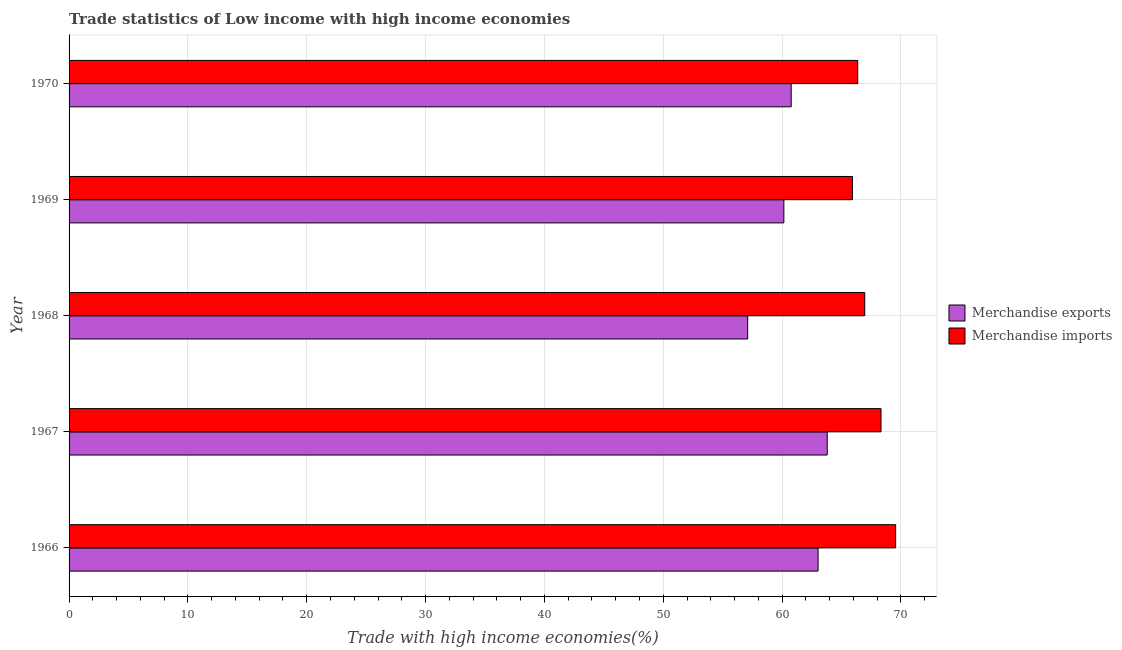Are the number of bars per tick equal to the number of legend labels?
Your answer should be very brief. Yes. Are the number of bars on each tick of the Y-axis equal?
Offer a very short reply. Yes. What is the label of the 4th group of bars from the top?
Your response must be concise. 1967. In how many cases, is the number of bars for a given year not equal to the number of legend labels?
Keep it short and to the point. 0. What is the merchandise exports in 1970?
Make the answer very short. 60.76. Across all years, what is the maximum merchandise exports?
Keep it short and to the point. 63.8. Across all years, what is the minimum merchandise exports?
Provide a succinct answer. 57.1. In which year was the merchandise exports maximum?
Your response must be concise. 1967. In which year was the merchandise exports minimum?
Make the answer very short. 1968. What is the total merchandise exports in the graph?
Offer a terse response. 304.84. What is the difference between the merchandise imports in 1967 and that in 1969?
Keep it short and to the point. 2.41. What is the difference between the merchandise imports in 1966 and the merchandise exports in 1967?
Ensure brevity in your answer.  5.76. What is the average merchandise imports per year?
Offer a terse response. 67.42. In the year 1967, what is the difference between the merchandise exports and merchandise imports?
Ensure brevity in your answer.  -4.53. What is the ratio of the merchandise imports in 1967 to that in 1969?
Give a very brief answer. 1.04. Is the merchandise exports in 1967 less than that in 1969?
Offer a very short reply. No. What is the difference between the highest and the second highest merchandise exports?
Keep it short and to the point. 0.77. What is the difference between the highest and the lowest merchandise imports?
Keep it short and to the point. 3.64. Is the sum of the merchandise exports in 1967 and 1969 greater than the maximum merchandise imports across all years?
Your answer should be compact. Yes. How many bars are there?
Ensure brevity in your answer.  10. Are all the bars in the graph horizontal?
Keep it short and to the point. Yes. What is the difference between two consecutive major ticks on the X-axis?
Provide a succinct answer. 10. Are the values on the major ticks of X-axis written in scientific E-notation?
Offer a terse response. No. Does the graph contain any zero values?
Keep it short and to the point. No. How many legend labels are there?
Ensure brevity in your answer.  2. What is the title of the graph?
Provide a succinct answer. Trade statistics of Low income with high income economies. What is the label or title of the X-axis?
Provide a short and direct response. Trade with high income economies(%). What is the Trade with high income economies(%) in Merchandise exports in 1966?
Ensure brevity in your answer.  63.03. What is the Trade with high income economies(%) in Merchandise imports in 1966?
Offer a terse response. 69.55. What is the Trade with high income economies(%) in Merchandise exports in 1967?
Make the answer very short. 63.8. What is the Trade with high income economies(%) in Merchandise imports in 1967?
Provide a succinct answer. 68.32. What is the Trade with high income economies(%) of Merchandise exports in 1968?
Ensure brevity in your answer.  57.1. What is the Trade with high income economies(%) in Merchandise imports in 1968?
Give a very brief answer. 66.95. What is the Trade with high income economies(%) in Merchandise exports in 1969?
Offer a very short reply. 60.15. What is the Trade with high income economies(%) of Merchandise imports in 1969?
Provide a succinct answer. 65.92. What is the Trade with high income economies(%) of Merchandise exports in 1970?
Provide a short and direct response. 60.76. What is the Trade with high income economies(%) of Merchandise imports in 1970?
Offer a terse response. 66.36. Across all years, what is the maximum Trade with high income economies(%) of Merchandise exports?
Give a very brief answer. 63.8. Across all years, what is the maximum Trade with high income economies(%) in Merchandise imports?
Your answer should be compact. 69.55. Across all years, what is the minimum Trade with high income economies(%) in Merchandise exports?
Provide a short and direct response. 57.1. Across all years, what is the minimum Trade with high income economies(%) in Merchandise imports?
Your answer should be very brief. 65.92. What is the total Trade with high income economies(%) of Merchandise exports in the graph?
Keep it short and to the point. 304.84. What is the total Trade with high income economies(%) of Merchandise imports in the graph?
Ensure brevity in your answer.  337.11. What is the difference between the Trade with high income economies(%) of Merchandise exports in 1966 and that in 1967?
Provide a succinct answer. -0.77. What is the difference between the Trade with high income economies(%) in Merchandise imports in 1966 and that in 1967?
Offer a very short reply. 1.23. What is the difference between the Trade with high income economies(%) in Merchandise exports in 1966 and that in 1968?
Offer a very short reply. 5.92. What is the difference between the Trade with high income economies(%) in Merchandise imports in 1966 and that in 1968?
Ensure brevity in your answer.  2.6. What is the difference between the Trade with high income economies(%) in Merchandise exports in 1966 and that in 1969?
Provide a succinct answer. 2.88. What is the difference between the Trade with high income economies(%) of Merchandise imports in 1966 and that in 1969?
Offer a very short reply. 3.64. What is the difference between the Trade with high income economies(%) of Merchandise exports in 1966 and that in 1970?
Your answer should be very brief. 2.26. What is the difference between the Trade with high income economies(%) of Merchandise imports in 1966 and that in 1970?
Offer a terse response. 3.19. What is the difference between the Trade with high income economies(%) of Merchandise exports in 1967 and that in 1968?
Offer a terse response. 6.69. What is the difference between the Trade with high income economies(%) in Merchandise imports in 1967 and that in 1968?
Make the answer very short. 1.37. What is the difference between the Trade with high income economies(%) of Merchandise exports in 1967 and that in 1969?
Provide a short and direct response. 3.65. What is the difference between the Trade with high income economies(%) of Merchandise imports in 1967 and that in 1969?
Offer a terse response. 2.41. What is the difference between the Trade with high income economies(%) of Merchandise exports in 1967 and that in 1970?
Your answer should be very brief. 3.03. What is the difference between the Trade with high income economies(%) of Merchandise imports in 1967 and that in 1970?
Give a very brief answer. 1.96. What is the difference between the Trade with high income economies(%) in Merchandise exports in 1968 and that in 1969?
Make the answer very short. -3.04. What is the difference between the Trade with high income economies(%) of Merchandise exports in 1968 and that in 1970?
Provide a succinct answer. -3.66. What is the difference between the Trade with high income economies(%) of Merchandise imports in 1968 and that in 1970?
Your answer should be compact. 0.59. What is the difference between the Trade with high income economies(%) in Merchandise exports in 1969 and that in 1970?
Give a very brief answer. -0.62. What is the difference between the Trade with high income economies(%) of Merchandise imports in 1969 and that in 1970?
Provide a short and direct response. -0.45. What is the difference between the Trade with high income economies(%) of Merchandise exports in 1966 and the Trade with high income economies(%) of Merchandise imports in 1967?
Provide a succinct answer. -5.3. What is the difference between the Trade with high income economies(%) in Merchandise exports in 1966 and the Trade with high income economies(%) in Merchandise imports in 1968?
Provide a short and direct response. -3.93. What is the difference between the Trade with high income economies(%) of Merchandise exports in 1966 and the Trade with high income economies(%) of Merchandise imports in 1969?
Your answer should be very brief. -2.89. What is the difference between the Trade with high income economies(%) of Merchandise exports in 1966 and the Trade with high income economies(%) of Merchandise imports in 1970?
Give a very brief answer. -3.34. What is the difference between the Trade with high income economies(%) in Merchandise exports in 1967 and the Trade with high income economies(%) in Merchandise imports in 1968?
Provide a succinct answer. -3.16. What is the difference between the Trade with high income economies(%) of Merchandise exports in 1967 and the Trade with high income economies(%) of Merchandise imports in 1969?
Keep it short and to the point. -2.12. What is the difference between the Trade with high income economies(%) in Merchandise exports in 1967 and the Trade with high income economies(%) in Merchandise imports in 1970?
Offer a very short reply. -2.57. What is the difference between the Trade with high income economies(%) of Merchandise exports in 1968 and the Trade with high income economies(%) of Merchandise imports in 1969?
Make the answer very short. -8.81. What is the difference between the Trade with high income economies(%) in Merchandise exports in 1968 and the Trade with high income economies(%) in Merchandise imports in 1970?
Ensure brevity in your answer.  -9.26. What is the difference between the Trade with high income economies(%) of Merchandise exports in 1969 and the Trade with high income economies(%) of Merchandise imports in 1970?
Your response must be concise. -6.22. What is the average Trade with high income economies(%) of Merchandise exports per year?
Provide a short and direct response. 60.97. What is the average Trade with high income economies(%) in Merchandise imports per year?
Give a very brief answer. 67.42. In the year 1966, what is the difference between the Trade with high income economies(%) of Merchandise exports and Trade with high income economies(%) of Merchandise imports?
Provide a short and direct response. -6.53. In the year 1967, what is the difference between the Trade with high income economies(%) in Merchandise exports and Trade with high income economies(%) in Merchandise imports?
Offer a very short reply. -4.53. In the year 1968, what is the difference between the Trade with high income economies(%) in Merchandise exports and Trade with high income economies(%) in Merchandise imports?
Give a very brief answer. -9.85. In the year 1969, what is the difference between the Trade with high income economies(%) in Merchandise exports and Trade with high income economies(%) in Merchandise imports?
Your answer should be compact. -5.77. In the year 1970, what is the difference between the Trade with high income economies(%) in Merchandise exports and Trade with high income economies(%) in Merchandise imports?
Ensure brevity in your answer.  -5.6. What is the ratio of the Trade with high income economies(%) of Merchandise exports in 1966 to that in 1967?
Give a very brief answer. 0.99. What is the ratio of the Trade with high income economies(%) in Merchandise imports in 1966 to that in 1967?
Your answer should be very brief. 1.02. What is the ratio of the Trade with high income economies(%) in Merchandise exports in 1966 to that in 1968?
Your response must be concise. 1.1. What is the ratio of the Trade with high income economies(%) of Merchandise imports in 1966 to that in 1968?
Your response must be concise. 1.04. What is the ratio of the Trade with high income economies(%) of Merchandise exports in 1966 to that in 1969?
Your answer should be very brief. 1.05. What is the ratio of the Trade with high income economies(%) of Merchandise imports in 1966 to that in 1969?
Provide a short and direct response. 1.06. What is the ratio of the Trade with high income economies(%) in Merchandise exports in 1966 to that in 1970?
Your response must be concise. 1.04. What is the ratio of the Trade with high income economies(%) of Merchandise imports in 1966 to that in 1970?
Ensure brevity in your answer.  1.05. What is the ratio of the Trade with high income economies(%) in Merchandise exports in 1967 to that in 1968?
Offer a very short reply. 1.12. What is the ratio of the Trade with high income economies(%) of Merchandise imports in 1967 to that in 1968?
Offer a very short reply. 1.02. What is the ratio of the Trade with high income economies(%) in Merchandise exports in 1967 to that in 1969?
Ensure brevity in your answer.  1.06. What is the ratio of the Trade with high income economies(%) in Merchandise imports in 1967 to that in 1969?
Offer a terse response. 1.04. What is the ratio of the Trade with high income economies(%) of Merchandise exports in 1967 to that in 1970?
Your response must be concise. 1.05. What is the ratio of the Trade with high income economies(%) of Merchandise imports in 1967 to that in 1970?
Your answer should be very brief. 1.03. What is the ratio of the Trade with high income economies(%) in Merchandise exports in 1968 to that in 1969?
Provide a succinct answer. 0.95. What is the ratio of the Trade with high income economies(%) of Merchandise imports in 1968 to that in 1969?
Offer a very short reply. 1.02. What is the ratio of the Trade with high income economies(%) of Merchandise exports in 1968 to that in 1970?
Provide a short and direct response. 0.94. What is the ratio of the Trade with high income economies(%) of Merchandise imports in 1968 to that in 1970?
Give a very brief answer. 1.01. What is the ratio of the Trade with high income economies(%) of Merchandise exports in 1969 to that in 1970?
Give a very brief answer. 0.99. What is the ratio of the Trade with high income economies(%) in Merchandise imports in 1969 to that in 1970?
Your answer should be very brief. 0.99. What is the difference between the highest and the second highest Trade with high income economies(%) in Merchandise exports?
Provide a succinct answer. 0.77. What is the difference between the highest and the second highest Trade with high income economies(%) in Merchandise imports?
Ensure brevity in your answer.  1.23. What is the difference between the highest and the lowest Trade with high income economies(%) in Merchandise exports?
Provide a succinct answer. 6.69. What is the difference between the highest and the lowest Trade with high income economies(%) of Merchandise imports?
Provide a succinct answer. 3.64. 